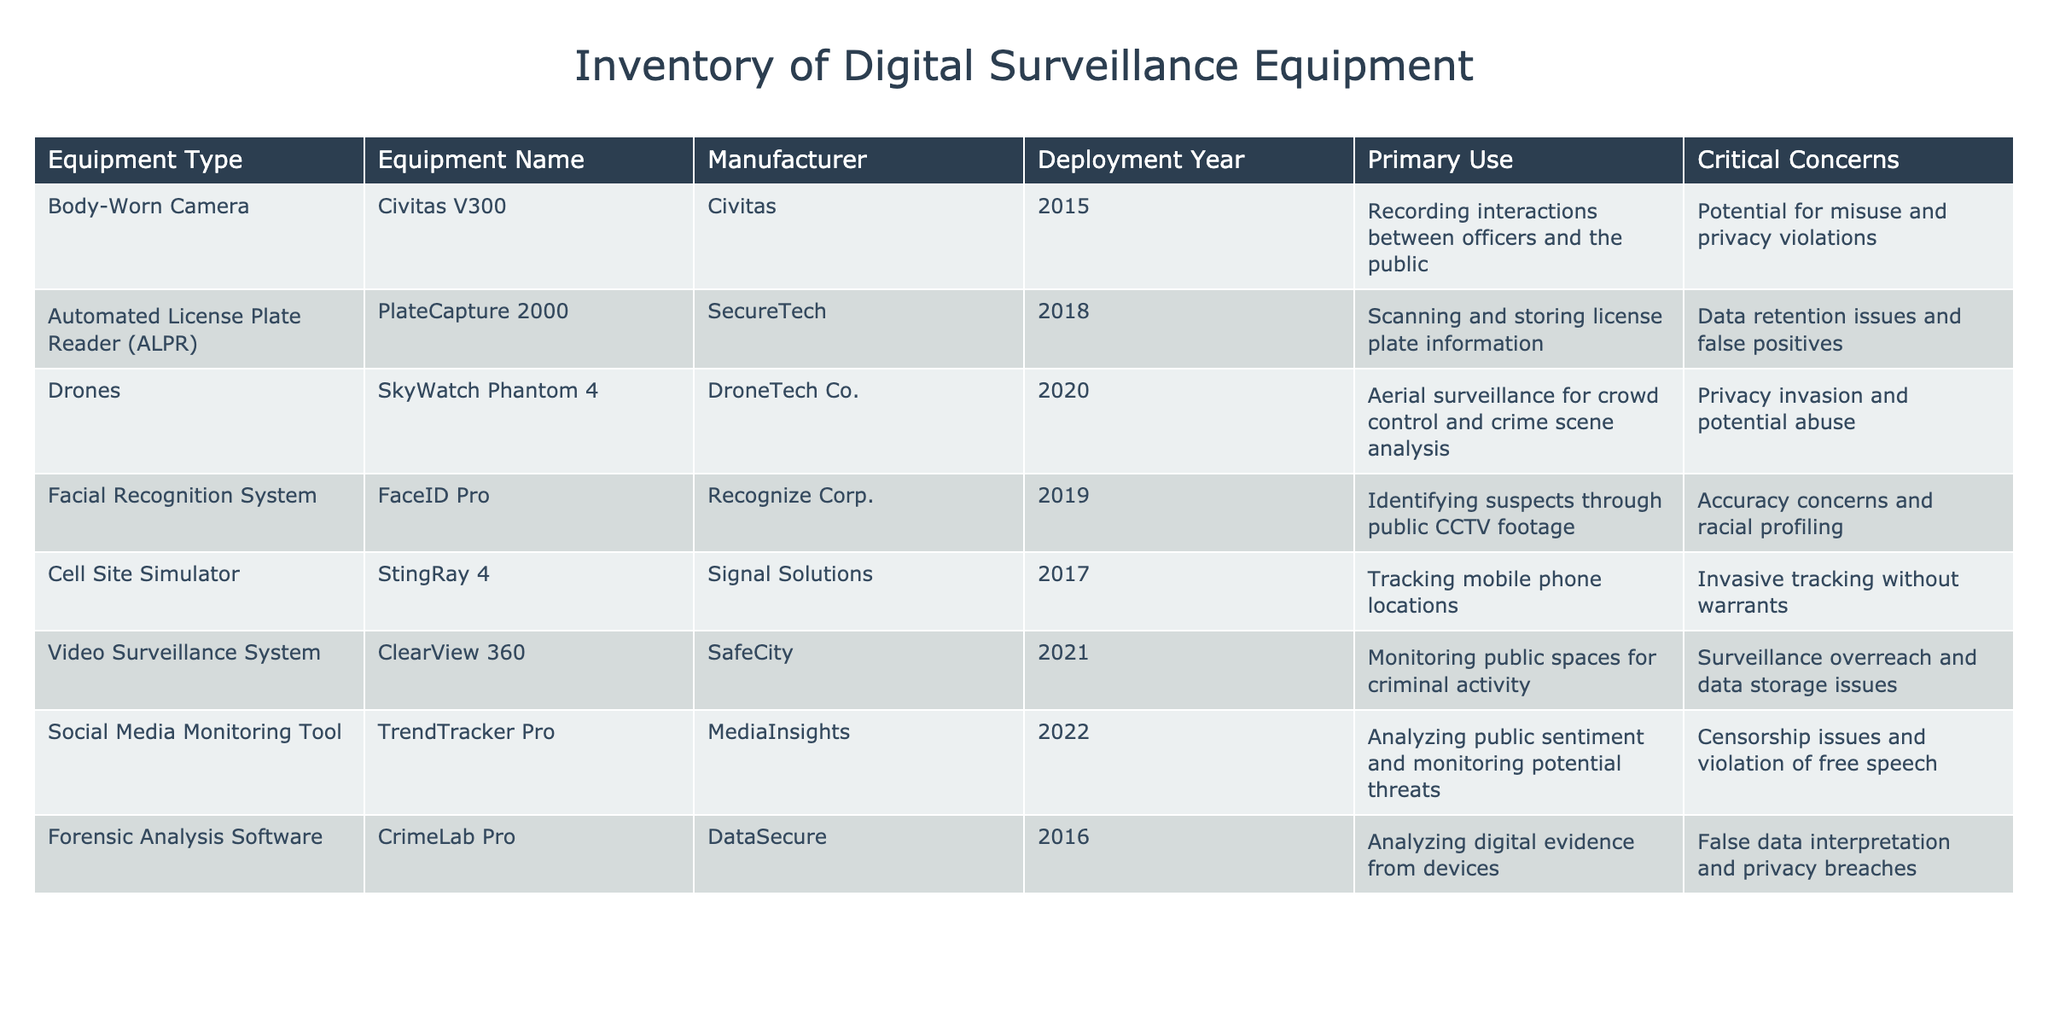What is the equipment name for automated license plate readers? The table lists "PlateCapture 2000" as the equipment name for automated license plate readers (ALPR).
Answer: PlateCapture 2000 Which equipment type was deployed in 2021? According to the table, the equipment type with deployment in 2021 is the Video Surveillance System.
Answer: Video Surveillance System How many pieces of equipment are focused on monitoring or surveillance? By reviewing the table, the following equipment types fall under monitoring or surveillance: Body-Worn Camera, Drones, Video Surveillance System, and Social Media Monitoring Tool. This totals four pieces of equipment.
Answer: 4 Is there a concern regarding privacy for the "FaceID Pro" equipment? Yes, the table mentions "Accuracy concerns and racial profiling" as critical concerns for the "FaceID Pro" facial recognition system.
Answer: Yes Identify the manufacturer of the "Civitas V300." The manufacturer of the "Civitas V300" is listed in the table as "Civitas."
Answer: Civitas What are the two primary concerns associated with the "StingRay 4" device? The table specifies that the "StingRay 4" cell site simulator is associated with "Invasive tracking without warrants" and is not used for lawful surveillance. This indicates significant privacy concerns.
Answer: Invasive tracking without warrants Which deployment year has the most pieces of equipment listed? Upon looking at the data, 2018 has two pieces of equipment: the Automated License Plate Reader and the "TrendTracker Pro." Thus, 2018 is the year with the most equipment listed in this table.
Answer: 2018 What is the primary use of the "CrimeLab Pro"? The primary use of the "CrimeLab Pro" is to analyze digital evidence from devices, as stated in the table.
Answer: Analyzing digital evidence from devices What is the average deployment year of the surveillance equipment listed? To find the average deployment year, sum the years: 2015 (1) + 2018 (2) + 2020 (3) + 2019 (4) + 2017 (5) + 2021 (6) + 2022 (7) + 2016 (8) = 161. Then divide by 8 (total number of devices), which results in an average: 161/8 = 20.125, making the approximate average deployment year 2018.
Answer: 2018 